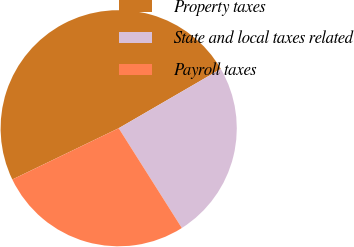Convert chart to OTSL. <chart><loc_0><loc_0><loc_500><loc_500><pie_chart><fcel>Property taxes<fcel>State and local taxes related<fcel>Payroll taxes<nl><fcel>48.78%<fcel>24.39%<fcel>26.83%<nl></chart> 